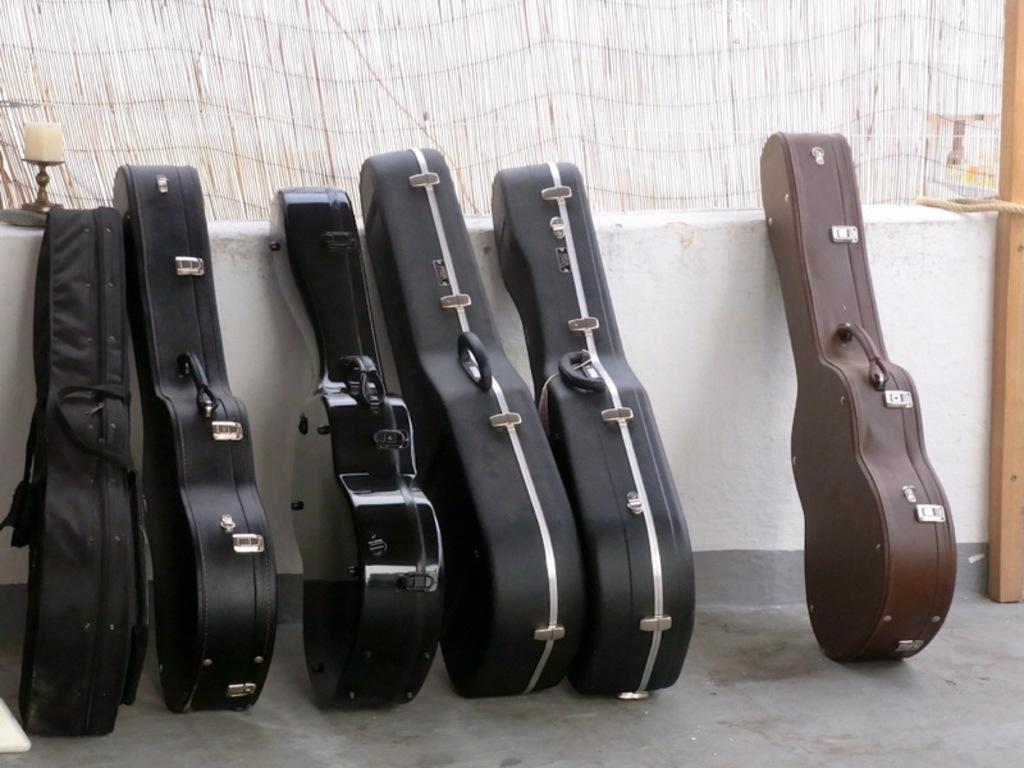What objects are related to music in the image? There are guitar cases in the image. What can be seen on the floor in the image? The floor is visible in the image. What type of light source is present in the image? There is a candle in the image. What type of material is present in the image? There is a rope and a wooden pole in the image. What type of cracker is being used as a decoration in the image? There is no cracker present in the image. What vegetables are being used as a centerpiece in the image? There are no vegetables present in the image. 